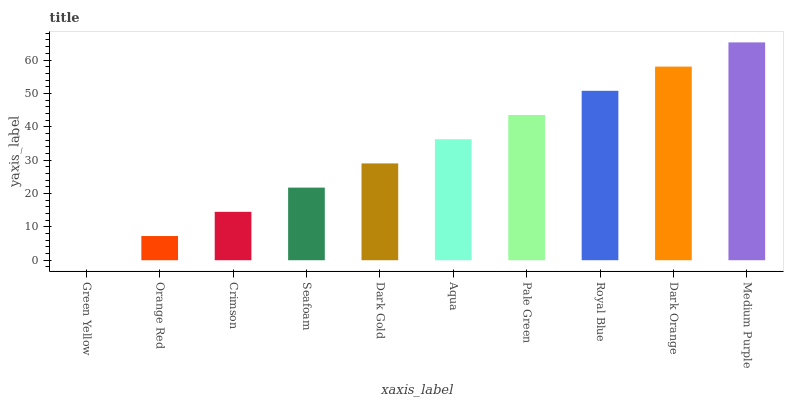Is Green Yellow the minimum?
Answer yes or no. Yes. Is Medium Purple the maximum?
Answer yes or no. Yes. Is Orange Red the minimum?
Answer yes or no. No. Is Orange Red the maximum?
Answer yes or no. No. Is Orange Red greater than Green Yellow?
Answer yes or no. Yes. Is Green Yellow less than Orange Red?
Answer yes or no. Yes. Is Green Yellow greater than Orange Red?
Answer yes or no. No. Is Orange Red less than Green Yellow?
Answer yes or no. No. Is Aqua the high median?
Answer yes or no. Yes. Is Dark Gold the low median?
Answer yes or no. Yes. Is Green Yellow the high median?
Answer yes or no. No. Is Aqua the low median?
Answer yes or no. No. 